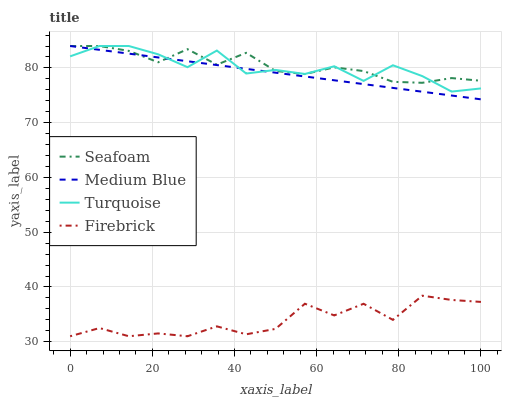Does Firebrick have the minimum area under the curve?
Answer yes or no. Yes. Does Seafoam have the maximum area under the curve?
Answer yes or no. Yes. Does Turquoise have the minimum area under the curve?
Answer yes or no. No. Does Turquoise have the maximum area under the curve?
Answer yes or no. No. Is Medium Blue the smoothest?
Answer yes or no. Yes. Is Firebrick the roughest?
Answer yes or no. Yes. Is Turquoise the smoothest?
Answer yes or no. No. Is Turquoise the roughest?
Answer yes or no. No. Does Firebrick have the lowest value?
Answer yes or no. Yes. Does Turquoise have the lowest value?
Answer yes or no. No. Does Seafoam have the highest value?
Answer yes or no. Yes. Is Firebrick less than Medium Blue?
Answer yes or no. Yes. Is Medium Blue greater than Firebrick?
Answer yes or no. Yes. Does Medium Blue intersect Seafoam?
Answer yes or no. Yes. Is Medium Blue less than Seafoam?
Answer yes or no. No. Is Medium Blue greater than Seafoam?
Answer yes or no. No. Does Firebrick intersect Medium Blue?
Answer yes or no. No. 